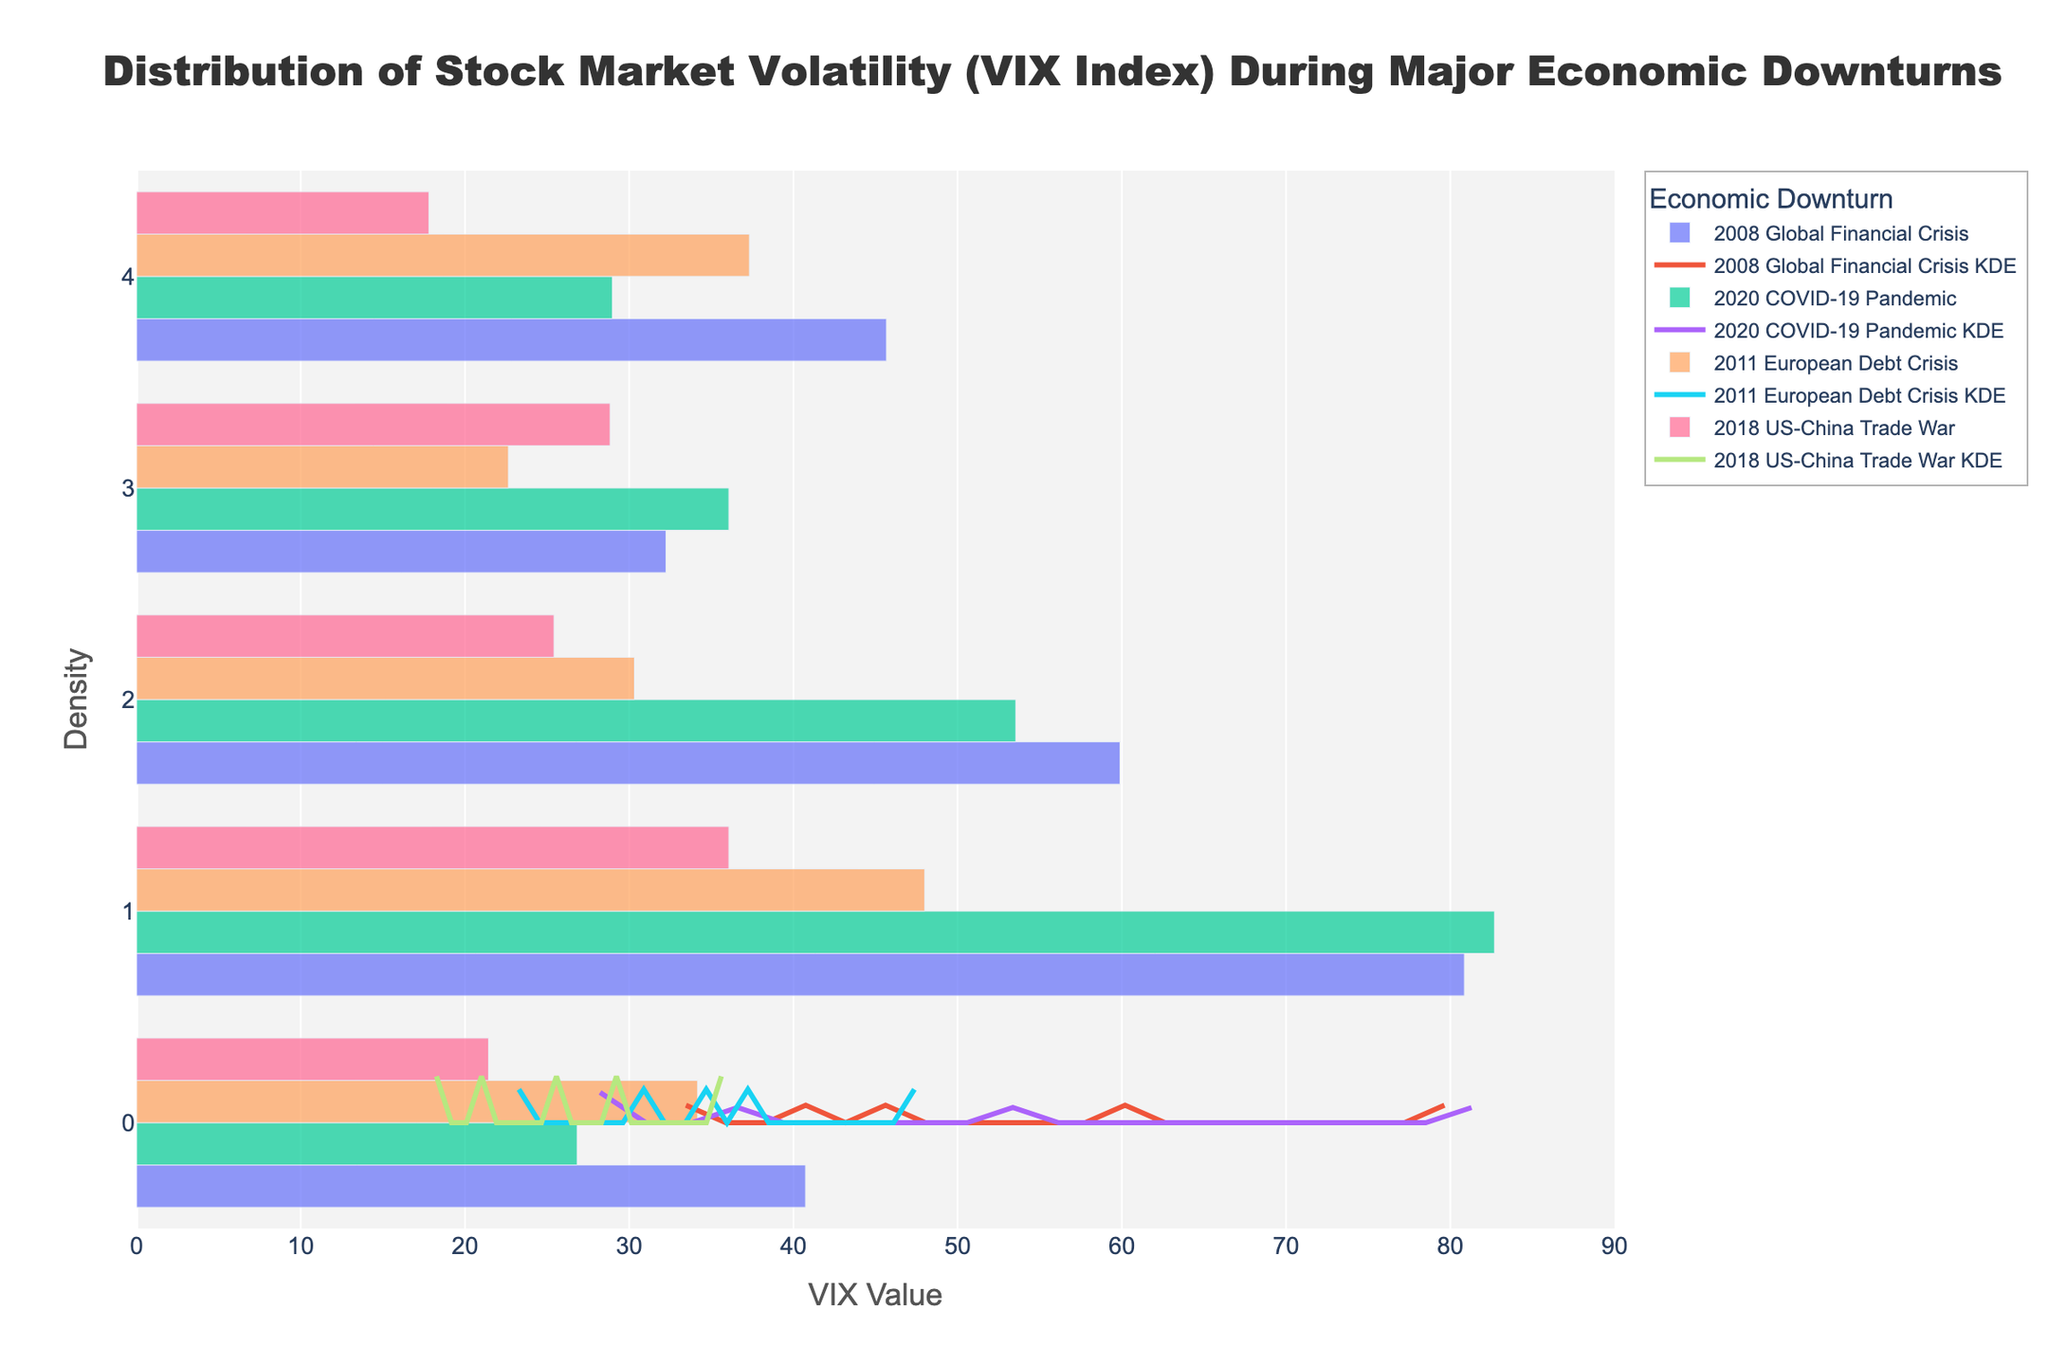What is the title of the figure? The title is typically displayed at the top of the figure. In this case, it reads "Distribution of Stock Market Volatility (VIX Index) During Major Economic Downturns"
Answer: Distribution of Stock Market Volatility (VIX Index) During Major Economic Downturns What does the x-axis represent in the figure? The labels on the x-axis indicate the 'VIX Value', which measures stock market volatility.
Answer: VIX Value Which economic downturn appears to have the largest peak in its KDE curve? By visually identifying the peak of each KDE curve, the peak of the 2008 Global Financial Crisis KDE curve is the highest.
Answer: 2008 Global Financial Crisis How many economic downturns are represented in the figure? By observing the legend, you can count the unique economic downturns listed in the figure. There are four: 2008 Global Financial Crisis, 2020 COVID-19 Pandemic, 2011 European Debt Crisis, and 2018 US-China Trade War.
Answer: Four What's the maximum VIX value recorded during the 2020 COVID-19 Pandemic? By looking at the histogram bars specifically for the 2020 COVID-19 Pandemic, you can identify the highest VIX value. It's 82.69.
Answer: 82.69 Which economic downturn has the smallest range of VIX values? By comparing the spread of histogram bars for each downturn, the 2011 European Debt Crisis has the smallest range because its bars are closely clustered.
Answer: 2011 European Debt Crisis What's the average of the highest VIX values during each economic downturn? Identify the highest VIX value for each downturn: 2008 (80.86), 2020 (82.69), 2011 (48.00), 2018 (36.07), then compute the average: (80.86 + 82.69 + 48.00 + 36.07) / 4.
Answer: 61.41 Which economic downturn has the lowest KDE curve value, and what is that value? By looking at the KDE curves, identify the downturn with the lowest point. The 2018 US-China Trade War has the lowest KDE curve value at zero for lower VIX values.
Answer: 0 (2018 US-China Trade War) Which economic downturn shows the most variability in VIX values based on the KDE curve? The width and spread of the KDE curve reflect variability. The 2020 COVID-19 Pandemic has a wide, spread-out KDE curve indicating high variability.
Answer: 2020 COVID-19 Pandemic Is there a common VIX value where the density appears highest across multiple downturns? By visually comparing the peaks of KDE curves, most curves peak around the VIX value of 30-40.
Answer: 30-40 